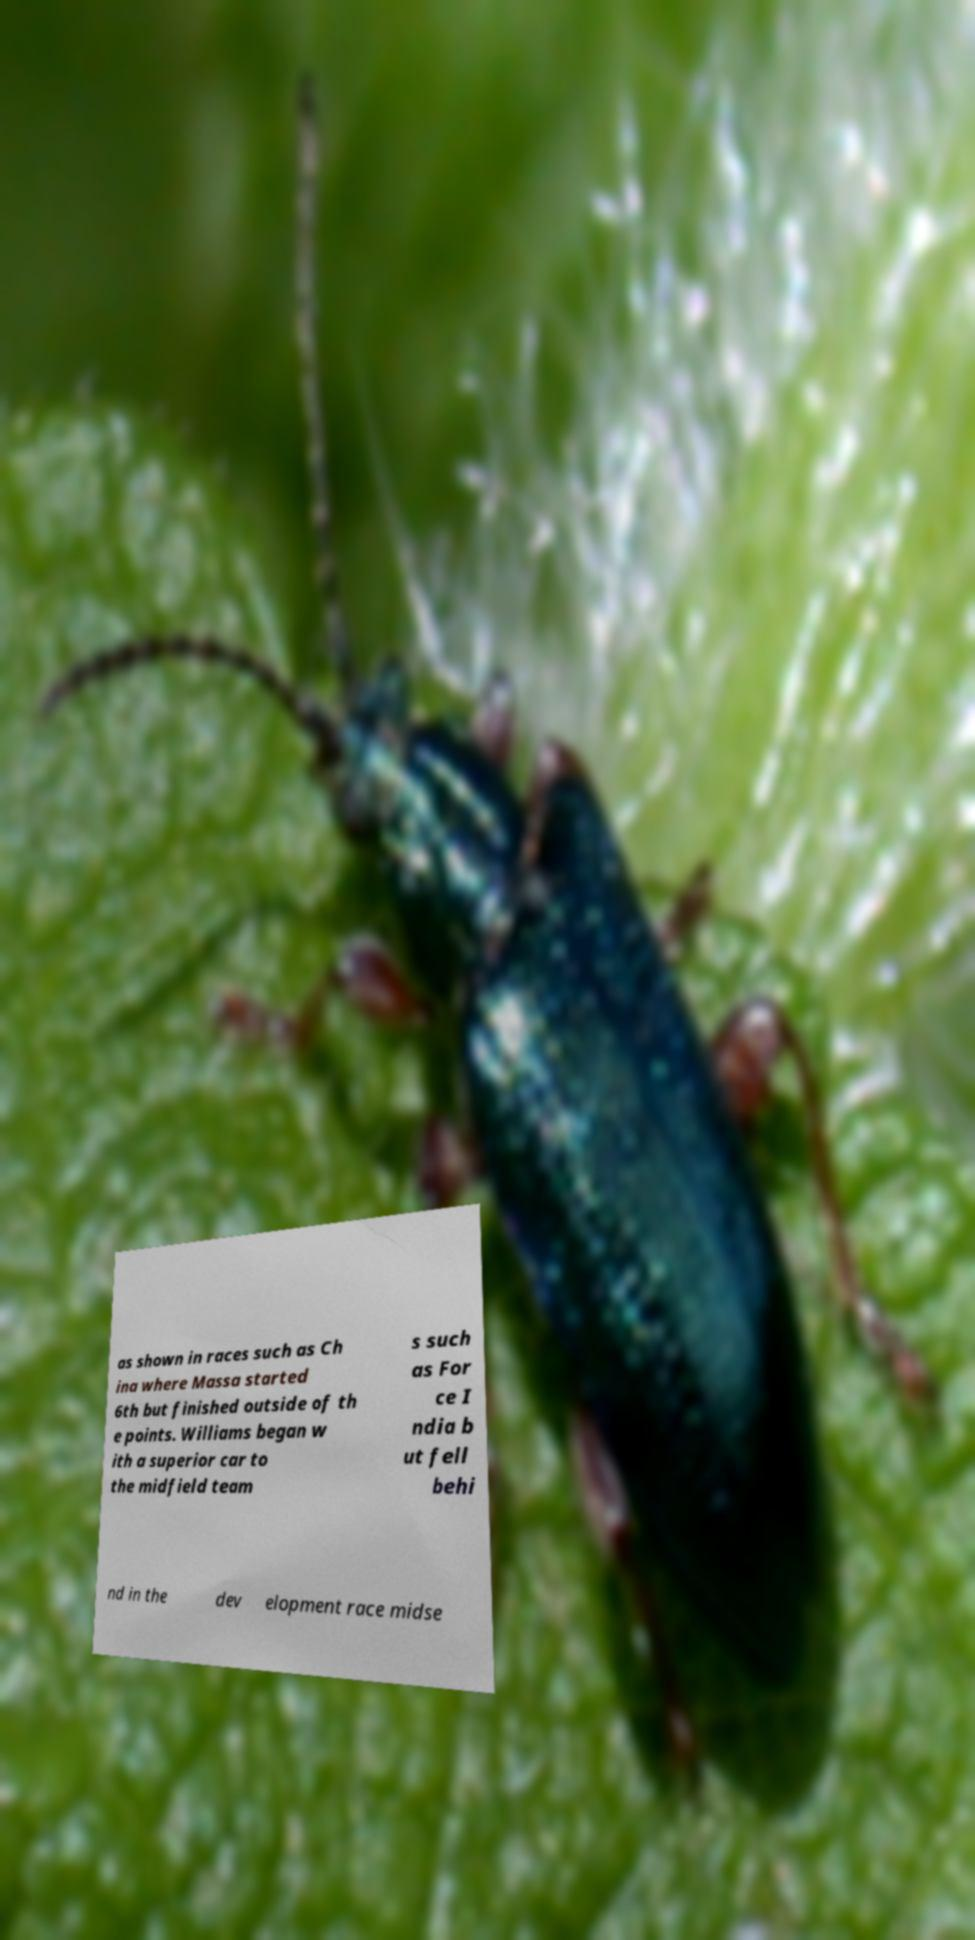For documentation purposes, I need the text within this image transcribed. Could you provide that? as shown in races such as Ch ina where Massa started 6th but finished outside of th e points. Williams began w ith a superior car to the midfield team s such as For ce I ndia b ut fell behi nd in the dev elopment race midse 